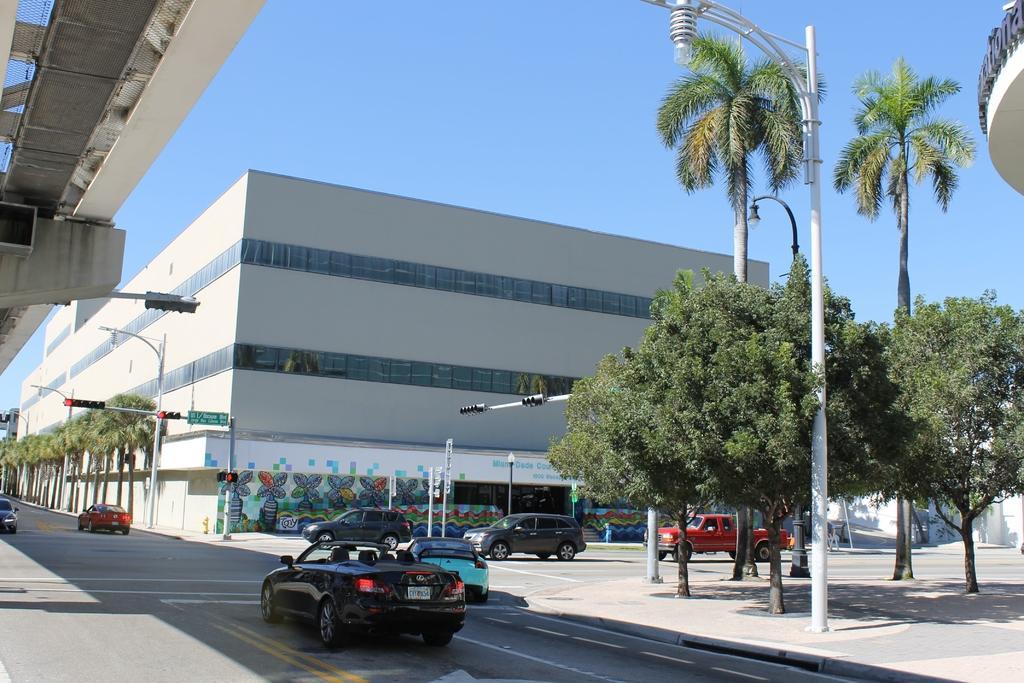Please provide a concise description of this image. In this image we can see flyover, sky, buildings, street lights, street poles, traffic poles, traffic signals, sign boards, motor vehicles on the road, trees and grills. 